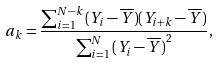Convert formula to latex. <formula><loc_0><loc_0><loc_500><loc_500>a _ { k } = \frac { { \sum \nolimits _ { i = 1 } ^ { N - k } { ( Y _ { i } - \overline { Y } ) } ( Y _ { i + k } - \overline { Y } ) } } { { \sum \nolimits _ { i = 1 } ^ { N } { ( Y _ { i } - \overline { Y } ) } ^ { 2 } } } ,</formula> 